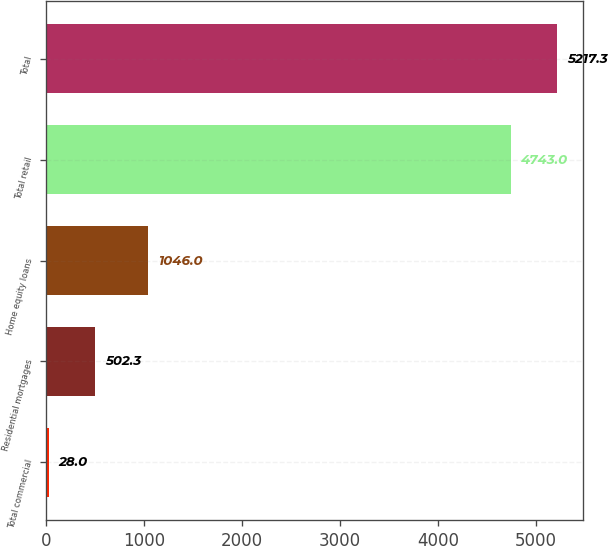Convert chart to OTSL. <chart><loc_0><loc_0><loc_500><loc_500><bar_chart><fcel>Total commercial<fcel>Residential mortgages<fcel>Home equity loans<fcel>Total retail<fcel>Total<nl><fcel>28<fcel>502.3<fcel>1046<fcel>4743<fcel>5217.3<nl></chart> 